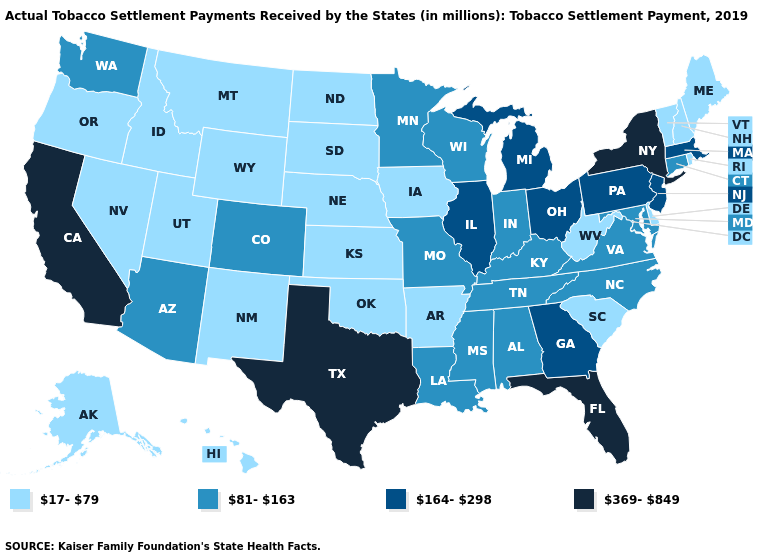Name the states that have a value in the range 81-163?
Quick response, please. Alabama, Arizona, Colorado, Connecticut, Indiana, Kentucky, Louisiana, Maryland, Minnesota, Mississippi, Missouri, North Carolina, Tennessee, Virginia, Washington, Wisconsin. Name the states that have a value in the range 17-79?
Quick response, please. Alaska, Arkansas, Delaware, Hawaii, Idaho, Iowa, Kansas, Maine, Montana, Nebraska, Nevada, New Hampshire, New Mexico, North Dakota, Oklahoma, Oregon, Rhode Island, South Carolina, South Dakota, Utah, Vermont, West Virginia, Wyoming. Among the states that border Nebraska , which have the lowest value?
Short answer required. Iowa, Kansas, South Dakota, Wyoming. Name the states that have a value in the range 81-163?
Keep it brief. Alabama, Arizona, Colorado, Connecticut, Indiana, Kentucky, Louisiana, Maryland, Minnesota, Mississippi, Missouri, North Carolina, Tennessee, Virginia, Washington, Wisconsin. Does the map have missing data?
Be succinct. No. What is the value of Nebraska?
Be succinct. 17-79. What is the value of Missouri?
Short answer required. 81-163. Among the states that border Delaware , which have the lowest value?
Short answer required. Maryland. What is the value of Michigan?
Keep it brief. 164-298. Name the states that have a value in the range 164-298?
Write a very short answer. Georgia, Illinois, Massachusetts, Michigan, New Jersey, Ohio, Pennsylvania. Does Missouri have the highest value in the MidWest?
Give a very brief answer. No. Name the states that have a value in the range 17-79?
Concise answer only. Alaska, Arkansas, Delaware, Hawaii, Idaho, Iowa, Kansas, Maine, Montana, Nebraska, Nevada, New Hampshire, New Mexico, North Dakota, Oklahoma, Oregon, Rhode Island, South Carolina, South Dakota, Utah, Vermont, West Virginia, Wyoming. What is the value of Maine?
Answer briefly. 17-79. Does California have a lower value than South Dakota?
Answer briefly. No. Which states have the lowest value in the USA?
Give a very brief answer. Alaska, Arkansas, Delaware, Hawaii, Idaho, Iowa, Kansas, Maine, Montana, Nebraska, Nevada, New Hampshire, New Mexico, North Dakota, Oklahoma, Oregon, Rhode Island, South Carolina, South Dakota, Utah, Vermont, West Virginia, Wyoming. 